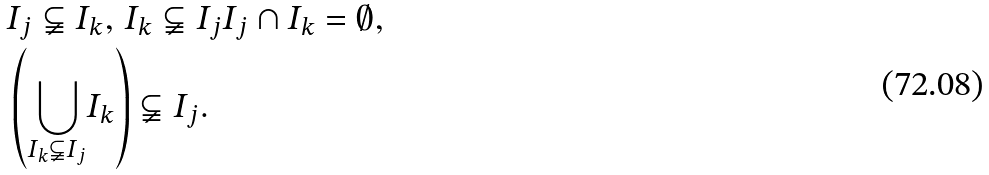<formula> <loc_0><loc_0><loc_500><loc_500>& I _ { j } \subsetneqq I _ { k } , \, I _ { k } \subsetneqq I _ { j } I _ { j } \cap I _ { k } = \emptyset , \\ & \left ( \underset { I _ { k } \subsetneqq I _ { j } } { \bigcup } I _ { k } \right ) \subsetneqq I _ { j } .</formula> 